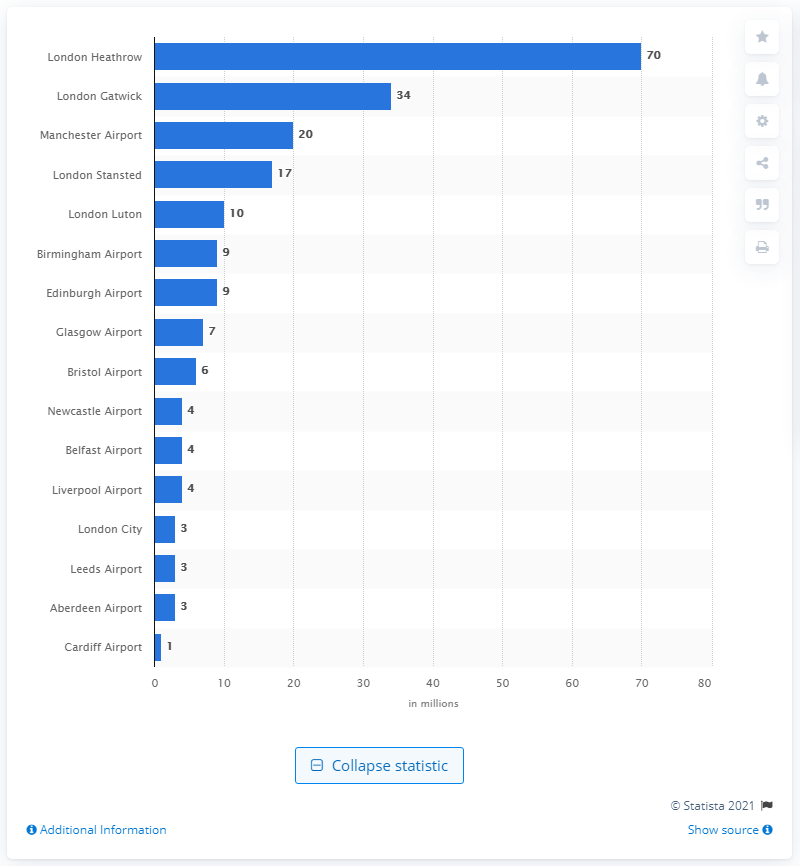Highlight a few significant elements in this photo. In 2013, Manchester Airport was the airport with the most number of passengers. London Heathrow Airport was the most frequently used airport in the United Kingdom in 2013. 